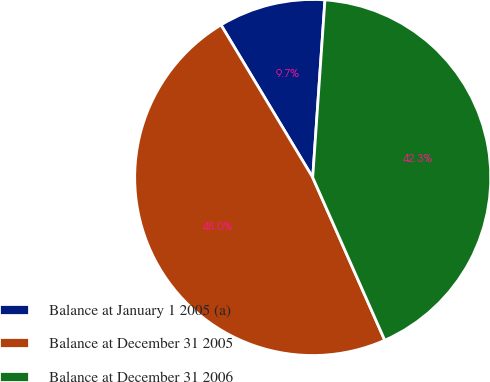<chart> <loc_0><loc_0><loc_500><loc_500><pie_chart><fcel>Balance at January 1 2005 (a)<fcel>Balance at December 31 2005<fcel>Balance at December 31 2006<nl><fcel>9.71%<fcel>48.02%<fcel>42.27%<nl></chart> 